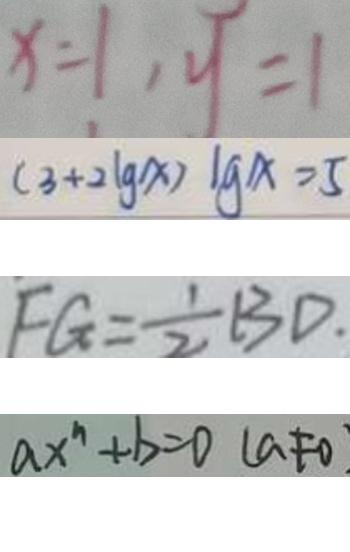<formula> <loc_0><loc_0><loc_500><loc_500>x = 1 , y = 1 
 ( 3 + 2 \lg x ) \lg x = 5 
 F G = \frac { 1 } { 2 } B D 
 a x ^ { n } + b = 0 ( a \neq 0</formula> 